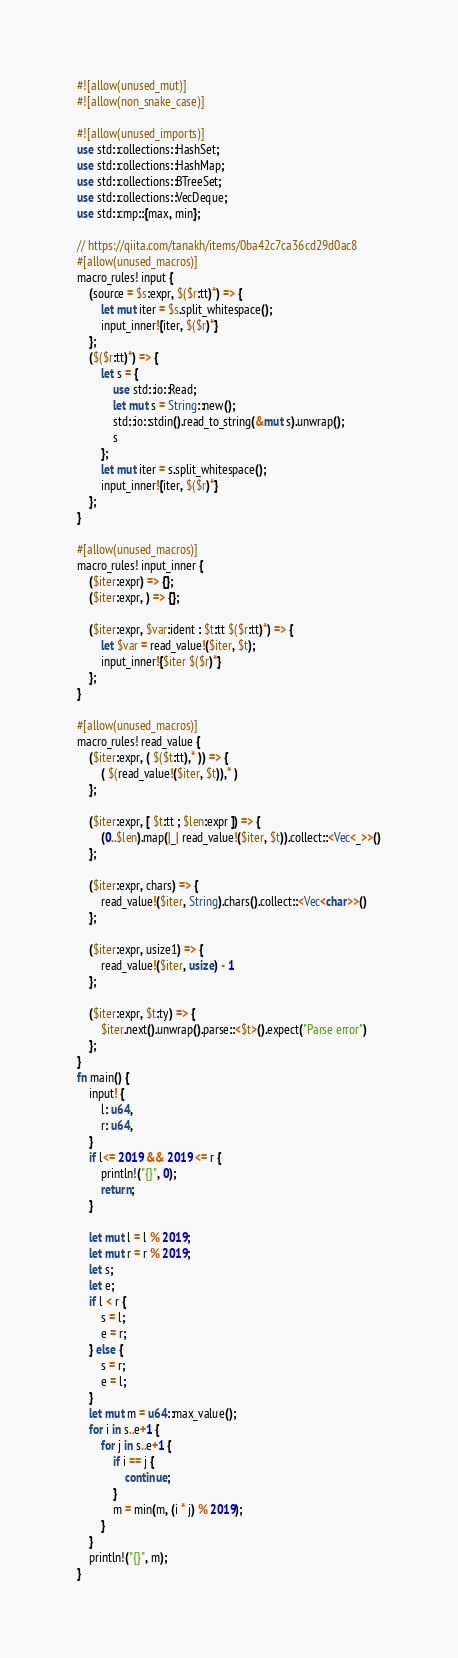Convert code to text. <code><loc_0><loc_0><loc_500><loc_500><_Rust_>#![allow(unused_mut)]
#![allow(non_snake_case)]

#![allow(unused_imports)]
use std::collections::HashSet;
use std::collections::HashMap;
use std::collections::BTreeSet;
use std::collections::VecDeque;
use std::cmp::{max, min};

// https://qiita.com/tanakh/items/0ba42c7ca36cd29d0ac8
#[allow(unused_macros)]
macro_rules! input {
    (source = $s:expr, $($r:tt)*) => {
        let mut iter = $s.split_whitespace();
        input_inner!{iter, $($r)*}
    };
    ($($r:tt)*) => {
        let s = {
            use std::io::Read;
            let mut s = String::new();
            std::io::stdin().read_to_string(&mut s).unwrap();
            s
        };
        let mut iter = s.split_whitespace();
        input_inner!{iter, $($r)*}
    };
}

#[allow(unused_macros)]
macro_rules! input_inner {
    ($iter:expr) => {};
    ($iter:expr, ) => {};

    ($iter:expr, $var:ident : $t:tt $($r:tt)*) => {
        let $var = read_value!($iter, $t);
        input_inner!{$iter $($r)*}
    };
}

#[allow(unused_macros)]
macro_rules! read_value {
    ($iter:expr, ( $($t:tt),* )) => {
        ( $(read_value!($iter, $t)),* )
    };

    ($iter:expr, [ $t:tt ; $len:expr ]) => {
        (0..$len).map(|_| read_value!($iter, $t)).collect::<Vec<_>>()
    };

    ($iter:expr, chars) => {
        read_value!($iter, String).chars().collect::<Vec<char>>()
    };

    ($iter:expr, usize1) => {
        read_value!($iter, usize) - 1
    };

    ($iter:expr, $t:ty) => {
        $iter.next().unwrap().parse::<$t>().expect("Parse error")
    };
}
fn main() {
    input! {
        l: u64,
        r: u64,
    }
    if l<= 2019 && 2019 <= r {
        println!("{}", 0);
        return;
    }

    let mut l = l % 2019;
    let mut r = r % 2019;
    let s;
    let e;
    if l < r {
        s = l;
        e = r;
    } else {
        s = r;
        e = l;
    }
    let mut m = u64::max_value();
    for i in s..e+1 {
        for j in s..e+1 {
            if i == j {
                continue;
            }
            m = min(m, (i * j) % 2019);
        }
    }
    println!("{}", m);
}</code> 